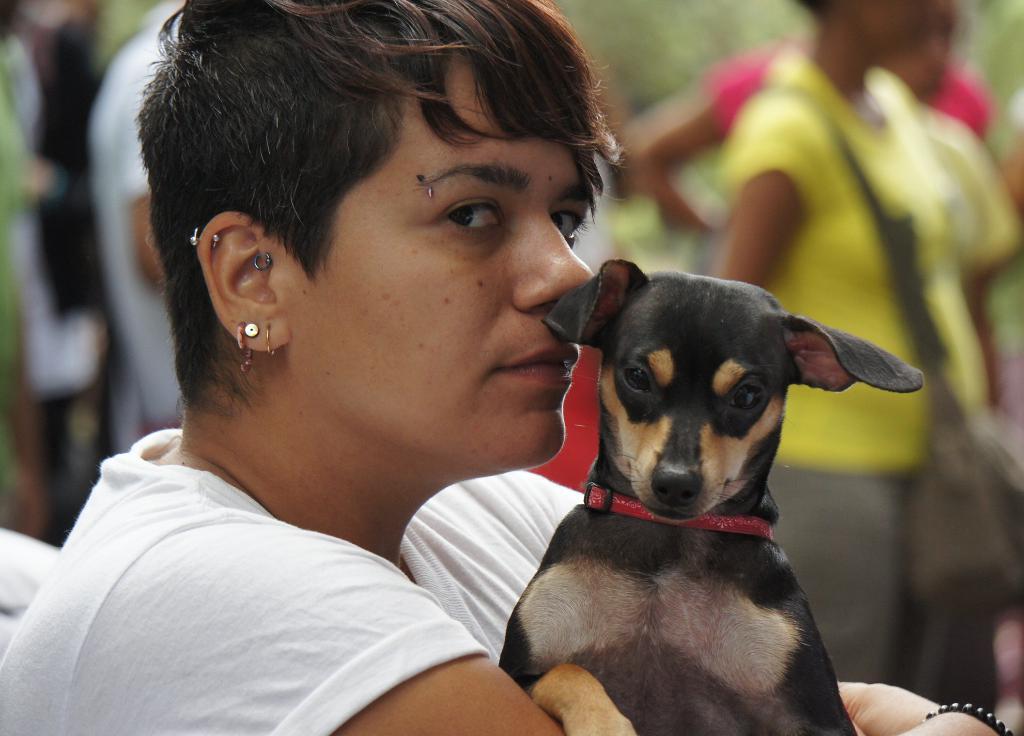Please provide a concise description of this image. In this image, we can see few peoples. The middle,woman is holding a dog and she is wearing earrings. And back side, few peoples are wear a bags. 